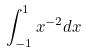Convert formula to latex. <formula><loc_0><loc_0><loc_500><loc_500>\int _ { - 1 } ^ { 1 } x ^ { - 2 } d x</formula> 